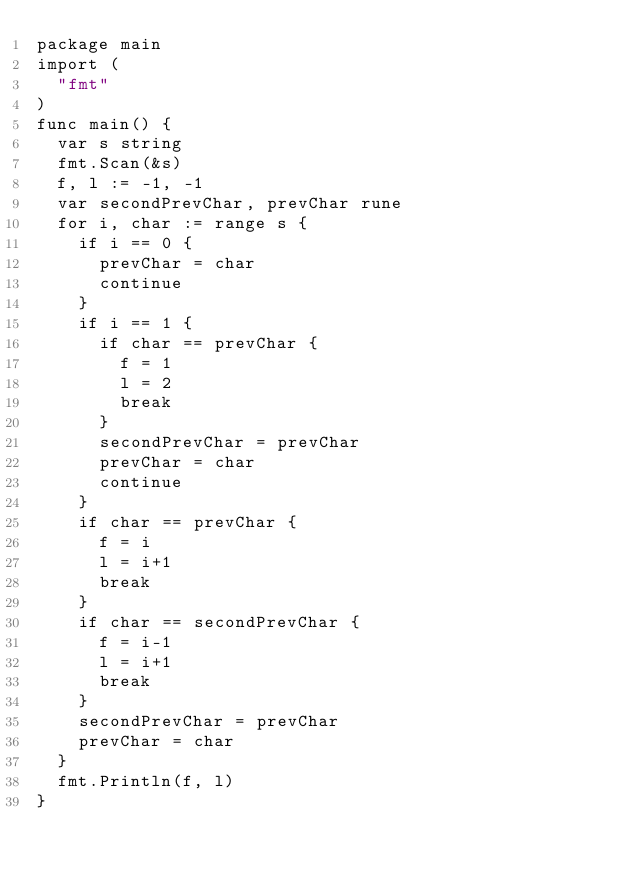Convert code to text. <code><loc_0><loc_0><loc_500><loc_500><_Go_>package main
import (
  "fmt"
)
func main() {
  var s string
  fmt.Scan(&s)
  f, l := -1, -1
  var secondPrevChar, prevChar rune
  for i, char := range s {
    if i == 0 {
      prevChar = char
      continue
    }
    if i == 1 {
      if char == prevChar {
        f = 1
        l = 2
        break
      }
      secondPrevChar = prevChar
      prevChar = char
      continue
    }
    if char == prevChar {
      f = i
      l = i+1
      break
    }
    if char == secondPrevChar {
      f = i-1
      l = i+1
      break
    }
    secondPrevChar = prevChar
    prevChar = char
  }
  fmt.Println(f, l)
}</code> 